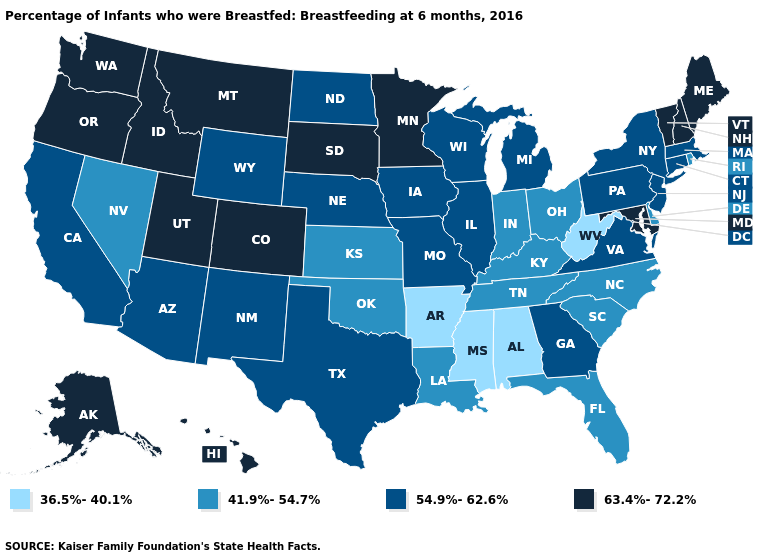Which states have the lowest value in the USA?
Write a very short answer. Alabama, Arkansas, Mississippi, West Virginia. Does Pennsylvania have the lowest value in the USA?
Keep it brief. No. What is the value of Pennsylvania?
Give a very brief answer. 54.9%-62.6%. Does Arizona have the lowest value in the USA?
Concise answer only. No. What is the value of Nebraska?
Quick response, please. 54.9%-62.6%. Which states have the highest value in the USA?
Give a very brief answer. Alaska, Colorado, Hawaii, Idaho, Maine, Maryland, Minnesota, Montana, New Hampshire, Oregon, South Dakota, Utah, Vermont, Washington. Does Florida have a lower value than Washington?
Answer briefly. Yes. Among the states that border Georgia , does Alabama have the lowest value?
Write a very short answer. Yes. Name the states that have a value in the range 36.5%-40.1%?
Keep it brief. Alabama, Arkansas, Mississippi, West Virginia. What is the value of Idaho?
Give a very brief answer. 63.4%-72.2%. Among the states that border Illinois , does Indiana have the lowest value?
Give a very brief answer. Yes. Among the states that border Indiana , which have the highest value?
Quick response, please. Illinois, Michigan. Which states hav the highest value in the Northeast?
Be succinct. Maine, New Hampshire, Vermont. Among the states that border Mississippi , does Tennessee have the lowest value?
Write a very short answer. No. Name the states that have a value in the range 41.9%-54.7%?
Give a very brief answer. Delaware, Florida, Indiana, Kansas, Kentucky, Louisiana, Nevada, North Carolina, Ohio, Oklahoma, Rhode Island, South Carolina, Tennessee. 